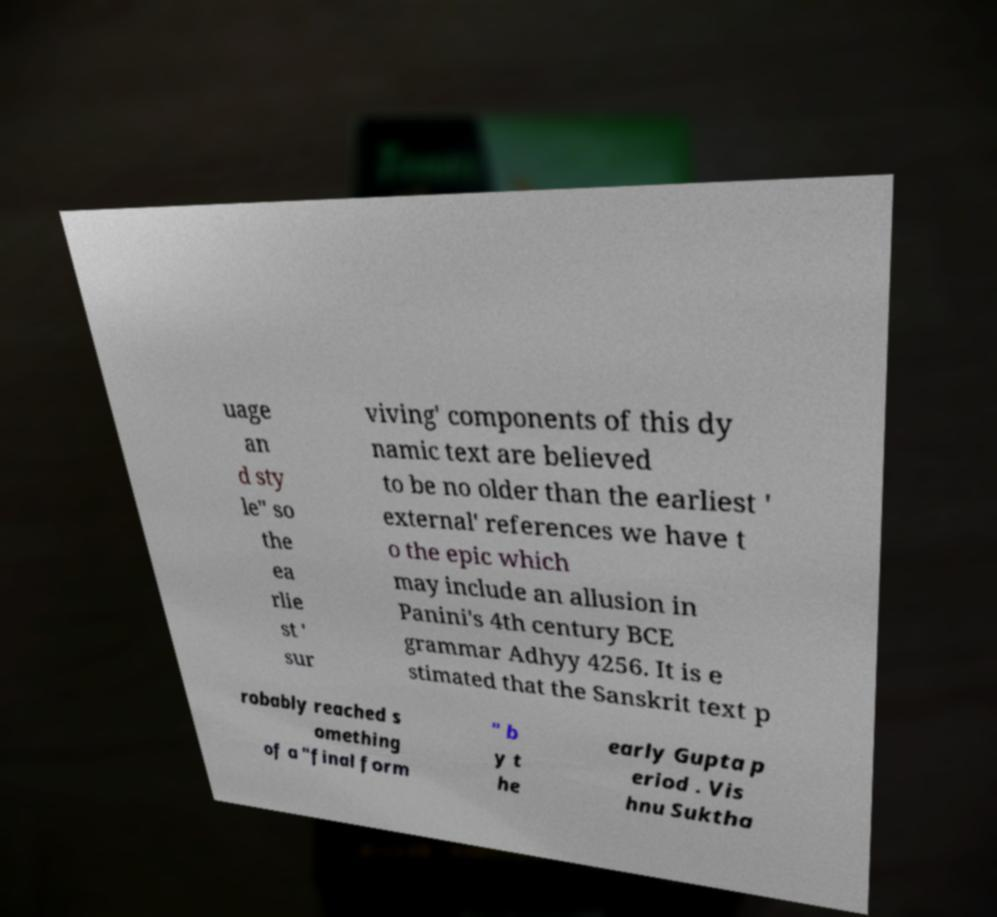There's text embedded in this image that I need extracted. Can you transcribe it verbatim? uage an d sty le" so the ea rlie st ' sur viving' components of this dy namic text are believed to be no older than the earliest ' external' references we have t o the epic which may include an allusion in Panini's 4th century BCE grammar Adhyy 4256. It is e stimated that the Sanskrit text p robably reached s omething of a "final form " b y t he early Gupta p eriod . Vis hnu Suktha 